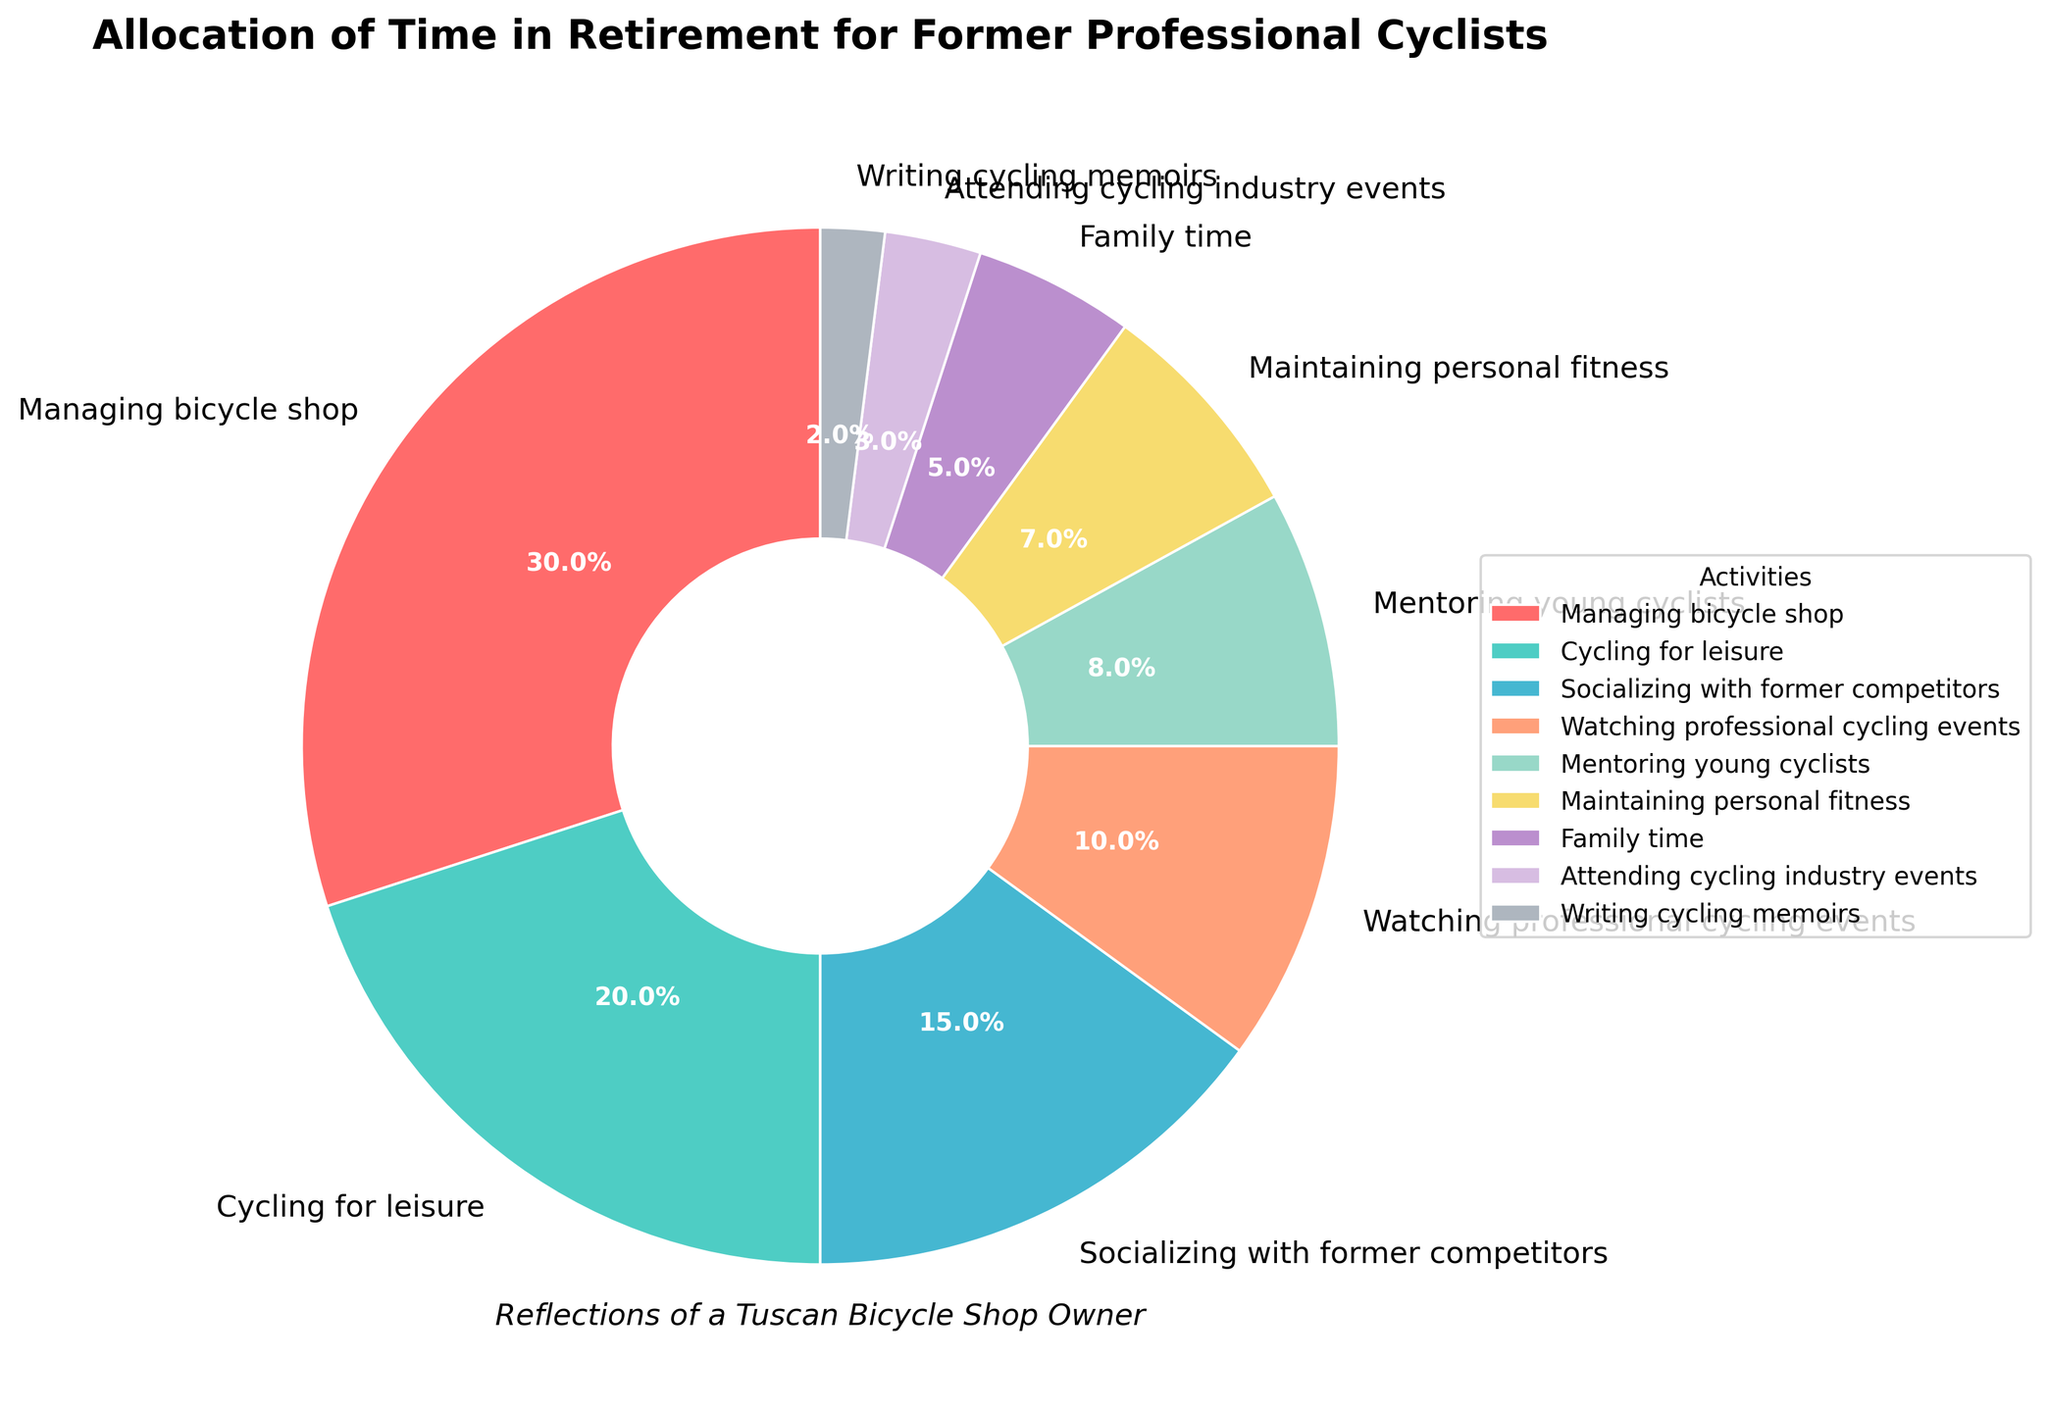Which activity takes up the most time in retirement? Refer to the pie chart and look for the activity segment with the largest percentage. "Managing bicycle shop" has the largest percentage at 30%.
Answer: Managing bicycle shop What is the combined percentage of time spent on socializing with former competitors and watching professional cycling events? Add the percentages for “socializing with former competitors” (15%) and “watching professional cycling events” (10%). So, 15 + 10 = 25%.
Answer: 25% Of all the activities, which one is allocated the least percentage of time? Look for the smallest segment on the pie chart. "Writing cycling memoirs" has the smallest percentage at 2%.
Answer: Writing cycling memoirs How much more time is spent managing the bicycle shop than mentoring young cyclists? Subtract the percentage for “mentoring young cyclists” (8%) from the percentage for “managing bicycle shop” (30%). So, 30 - 8 = 22%.
Answer: 22% Which activities together account for more than half of the total time allocated? Sum the percentages starting from the largest until exceeding 50%. "Managing bicycle shop" (30%) + "Cycling for leisure" (20%) total 50%, so adding any other activity like “Socializing with former competitors” (15%) will exceed 50%.
Answer: Managing bicycle shop, Cycling for leisure If we combine the percentages of attending cycling industry events and writing cycling memoirs, do they add up to over 5%? Add the percentages for “attending cycling industry events” (3%) and “writing cycling memoirs” (2%). So, 3 + 2 = 5%, which is not over 5%.
Answer: No What is the difference in percentage between time spent on maintaining personal fitness and family time? Subtract the percentage for “family time” (5%) from the percentage for “maintaining personal fitness” (7%). So, 7 - 5 = 2%.
Answer: 2% Are there more activities with a time allocation greater than 10% or less than 10%? Count the activities with more than 10%: Managing bicycle shop, Cycling for leisure, Socializing with former competitors, 3 total. Count the activities with less than 10%: Watching professional cycling events, Mentoring young cyclists, Maintaining personal fitness, Family time, Attending cycling industry events, Writing cycling memoirs, 6 total.
Answer: Less than 10% What percentage of time is collectively spent on mentoring young cyclists, maintaining personal fitness, and family time? Add the percentages for “mentoring young cyclists” (8%), “maintaining personal fitness” (7%), and “family time” (5%). So, 8 + 7 + 5 = 20%.
Answer: 20% 